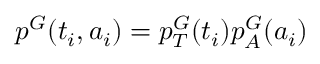<formula> <loc_0><loc_0><loc_500><loc_500>p ^ { G } ( t _ { i } , a _ { i } ) = p _ { T } ^ { G } ( t _ { i } ) p _ { A } ^ { G } ( a _ { i } )</formula> 